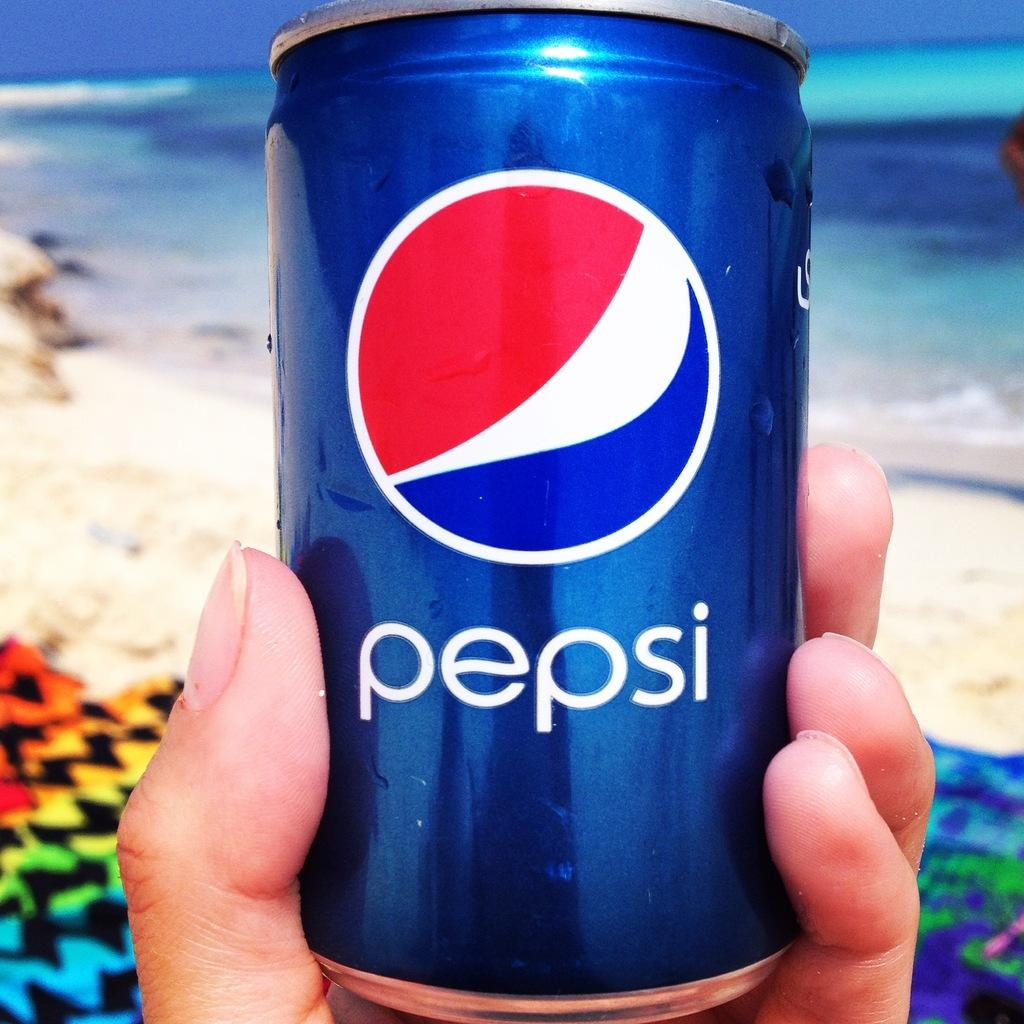<image>
Present a compact description of the photo's key features. A hand holding up a can of Pepsi. 